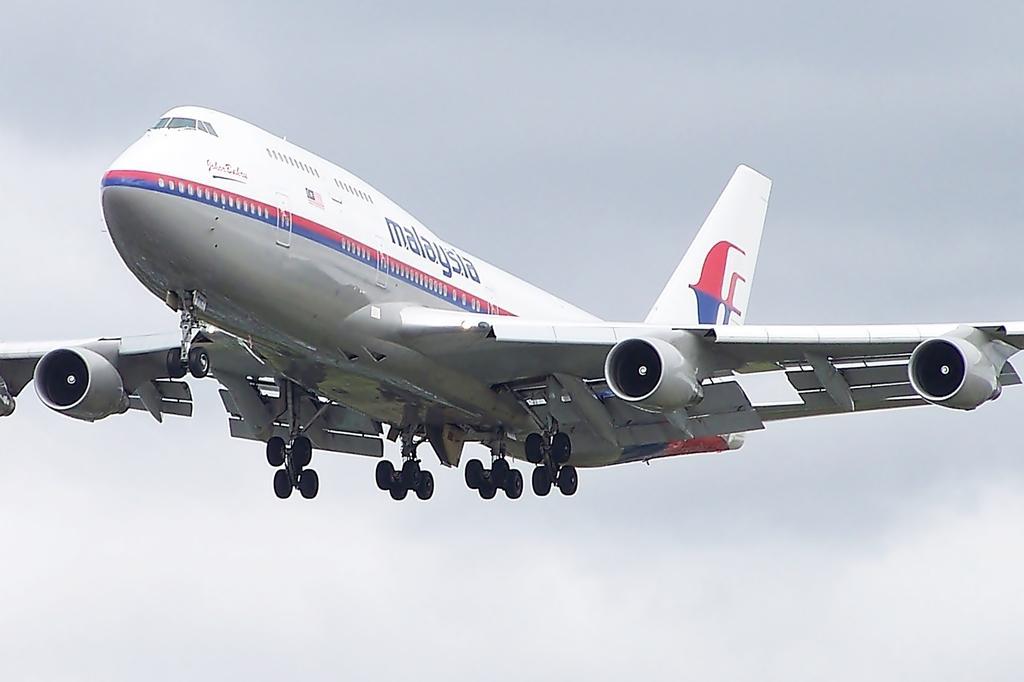Can you describe this image briefly? In this picture we can see an aeroplane is flying in the sky. 